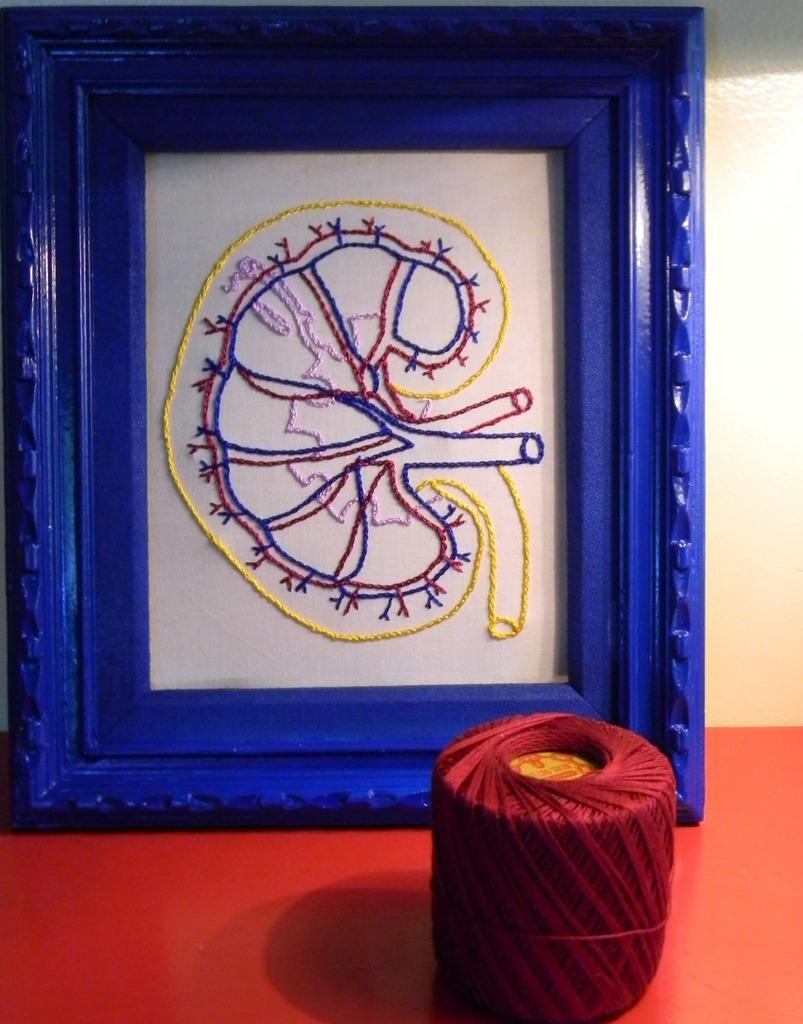In one or two sentences, can you explain what this image depicts? In the foreground of the picture there is a frame and there is thread, they are placed on a table. 